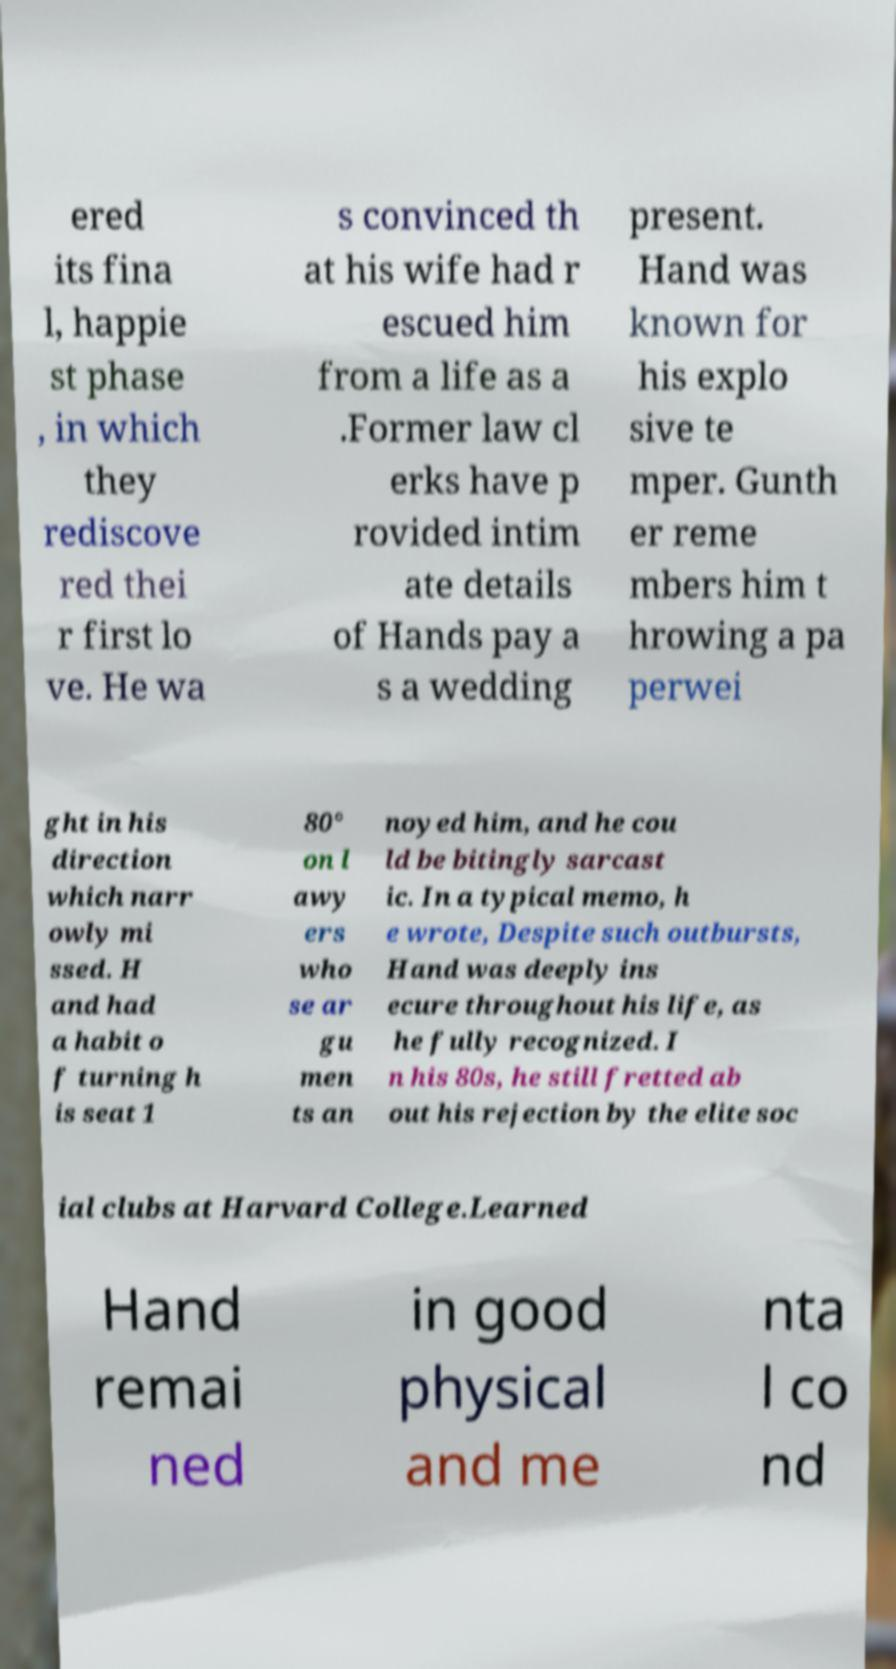Please identify and transcribe the text found in this image. ered its fina l, happie st phase , in which they rediscove red thei r first lo ve. He wa s convinced th at his wife had r escued him from a life as a .Former law cl erks have p rovided intim ate details of Hands pay a s a wedding present. Hand was known for his explo sive te mper. Gunth er reme mbers him t hrowing a pa perwei ght in his direction which narr owly mi ssed. H and had a habit o f turning h is seat 1 80° on l awy ers who se ar gu men ts an noyed him, and he cou ld be bitingly sarcast ic. In a typical memo, h e wrote, Despite such outbursts, Hand was deeply ins ecure throughout his life, as he fully recognized. I n his 80s, he still fretted ab out his rejection by the elite soc ial clubs at Harvard College.Learned Hand remai ned in good physical and me nta l co nd 